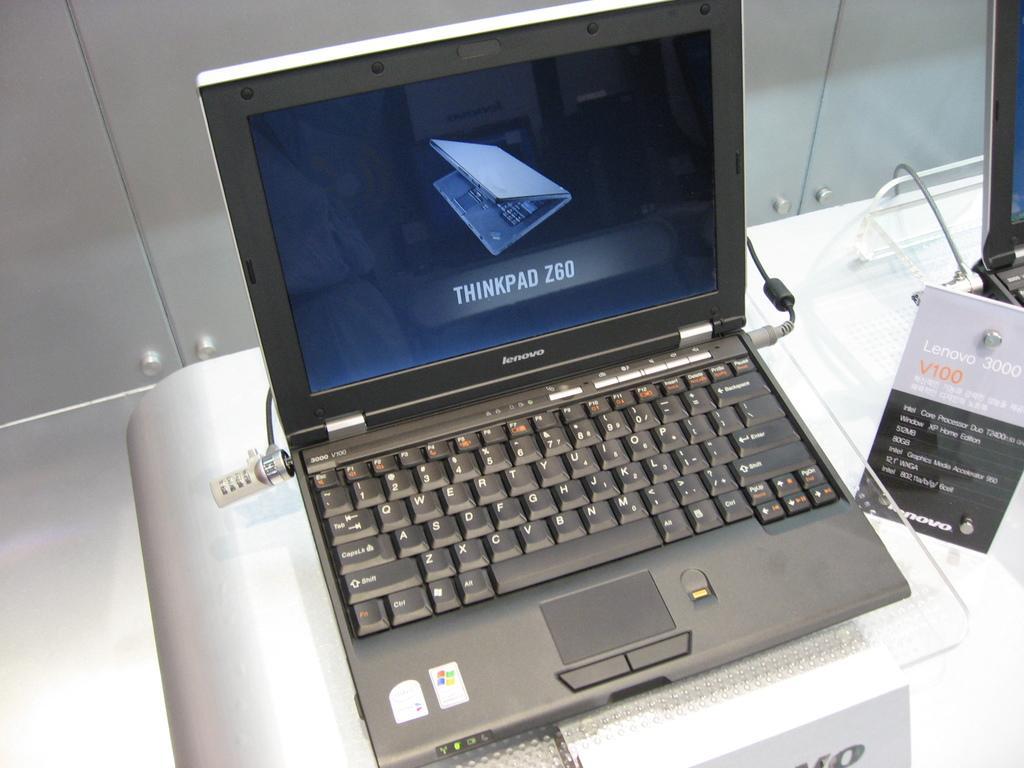Please provide a concise description of this image. In the center of the image there is a laptop placed on the table. In the background there is a wall. 